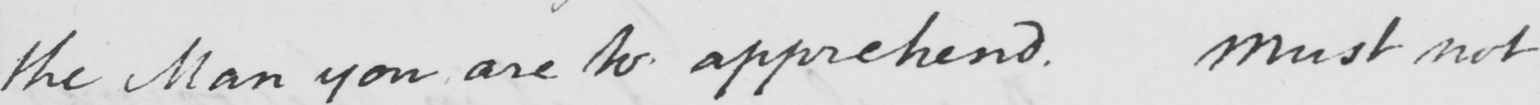Transcribe the text shown in this historical manuscript line. the Man you are to apprehend . Must not 